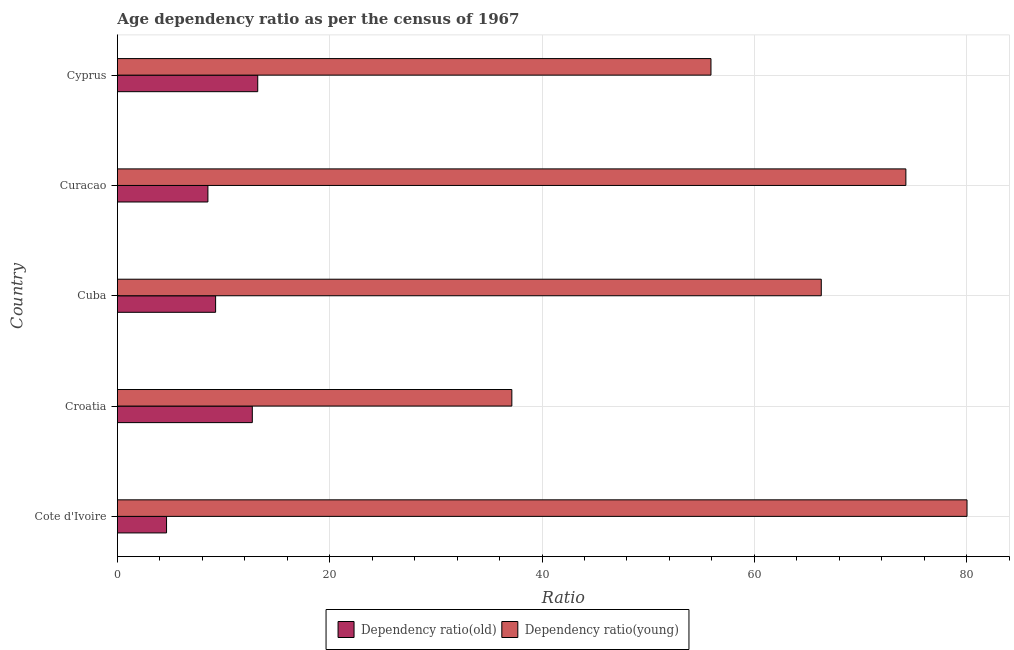Are the number of bars per tick equal to the number of legend labels?
Your answer should be compact. Yes. Are the number of bars on each tick of the Y-axis equal?
Give a very brief answer. Yes. What is the label of the 2nd group of bars from the top?
Ensure brevity in your answer.  Curacao. What is the age dependency ratio(old) in Curacao?
Provide a short and direct response. 8.52. Across all countries, what is the maximum age dependency ratio(young)?
Ensure brevity in your answer.  80.03. Across all countries, what is the minimum age dependency ratio(old)?
Give a very brief answer. 4.63. In which country was the age dependency ratio(old) maximum?
Give a very brief answer. Cyprus. In which country was the age dependency ratio(young) minimum?
Give a very brief answer. Croatia. What is the total age dependency ratio(old) in the graph?
Make the answer very short. 48.33. What is the difference between the age dependency ratio(old) in Cote d'Ivoire and that in Cyprus?
Your answer should be compact. -8.59. What is the difference between the age dependency ratio(young) in Croatia and the age dependency ratio(old) in Cyprus?
Keep it short and to the point. 23.94. What is the average age dependency ratio(young) per country?
Make the answer very short. 62.73. What is the difference between the age dependency ratio(old) and age dependency ratio(young) in Cuba?
Make the answer very short. -57.05. In how many countries, is the age dependency ratio(young) greater than 24 ?
Offer a very short reply. 5. What is the ratio of the age dependency ratio(old) in Cote d'Ivoire to that in Cyprus?
Offer a very short reply. 0.35. Is the age dependency ratio(old) in Cote d'Ivoire less than that in Cyprus?
Offer a terse response. Yes. What is the difference between the highest and the second highest age dependency ratio(young)?
Your answer should be very brief. 5.76. What is the difference between the highest and the lowest age dependency ratio(old)?
Provide a short and direct response. 8.59. In how many countries, is the age dependency ratio(old) greater than the average age dependency ratio(old) taken over all countries?
Give a very brief answer. 2. What does the 2nd bar from the top in Cuba represents?
Ensure brevity in your answer.  Dependency ratio(old). What does the 2nd bar from the bottom in Croatia represents?
Provide a short and direct response. Dependency ratio(young). Are all the bars in the graph horizontal?
Your answer should be compact. Yes. Are the values on the major ticks of X-axis written in scientific E-notation?
Offer a terse response. No. Does the graph contain any zero values?
Give a very brief answer. No. Does the graph contain grids?
Give a very brief answer. Yes. What is the title of the graph?
Ensure brevity in your answer.  Age dependency ratio as per the census of 1967. What is the label or title of the X-axis?
Ensure brevity in your answer.  Ratio. What is the Ratio of Dependency ratio(old) in Cote d'Ivoire?
Keep it short and to the point. 4.63. What is the Ratio of Dependency ratio(young) in Cote d'Ivoire?
Your answer should be very brief. 80.03. What is the Ratio of Dependency ratio(old) in Croatia?
Offer a very short reply. 12.71. What is the Ratio of Dependency ratio(young) in Croatia?
Make the answer very short. 37.15. What is the Ratio in Dependency ratio(old) in Cuba?
Offer a very short reply. 9.25. What is the Ratio of Dependency ratio(young) in Cuba?
Offer a very short reply. 66.3. What is the Ratio of Dependency ratio(old) in Curacao?
Your answer should be compact. 8.52. What is the Ratio of Dependency ratio(young) in Curacao?
Offer a terse response. 74.27. What is the Ratio in Dependency ratio(old) in Cyprus?
Your response must be concise. 13.22. What is the Ratio in Dependency ratio(young) in Cyprus?
Your answer should be compact. 55.91. Across all countries, what is the maximum Ratio in Dependency ratio(old)?
Offer a terse response. 13.22. Across all countries, what is the maximum Ratio in Dependency ratio(young)?
Make the answer very short. 80.03. Across all countries, what is the minimum Ratio of Dependency ratio(old)?
Provide a succinct answer. 4.63. Across all countries, what is the minimum Ratio in Dependency ratio(young)?
Make the answer very short. 37.15. What is the total Ratio in Dependency ratio(old) in the graph?
Keep it short and to the point. 48.33. What is the total Ratio of Dependency ratio(young) in the graph?
Provide a succinct answer. 313.66. What is the difference between the Ratio of Dependency ratio(old) in Cote d'Ivoire and that in Croatia?
Make the answer very short. -8.08. What is the difference between the Ratio of Dependency ratio(young) in Cote d'Ivoire and that in Croatia?
Your response must be concise. 42.87. What is the difference between the Ratio in Dependency ratio(old) in Cote d'Ivoire and that in Cuba?
Your answer should be very brief. -4.62. What is the difference between the Ratio in Dependency ratio(young) in Cote d'Ivoire and that in Cuba?
Your response must be concise. 13.73. What is the difference between the Ratio of Dependency ratio(old) in Cote d'Ivoire and that in Curacao?
Offer a very short reply. -3.9. What is the difference between the Ratio in Dependency ratio(young) in Cote d'Ivoire and that in Curacao?
Provide a short and direct response. 5.76. What is the difference between the Ratio of Dependency ratio(old) in Cote d'Ivoire and that in Cyprus?
Your response must be concise. -8.59. What is the difference between the Ratio in Dependency ratio(young) in Cote d'Ivoire and that in Cyprus?
Make the answer very short. 24.12. What is the difference between the Ratio in Dependency ratio(old) in Croatia and that in Cuba?
Offer a terse response. 3.46. What is the difference between the Ratio in Dependency ratio(young) in Croatia and that in Cuba?
Your answer should be very brief. -29.15. What is the difference between the Ratio of Dependency ratio(old) in Croatia and that in Curacao?
Give a very brief answer. 4.18. What is the difference between the Ratio of Dependency ratio(young) in Croatia and that in Curacao?
Ensure brevity in your answer.  -37.12. What is the difference between the Ratio in Dependency ratio(old) in Croatia and that in Cyprus?
Keep it short and to the point. -0.51. What is the difference between the Ratio of Dependency ratio(young) in Croatia and that in Cyprus?
Provide a succinct answer. -18.76. What is the difference between the Ratio of Dependency ratio(old) in Cuba and that in Curacao?
Your response must be concise. 0.73. What is the difference between the Ratio in Dependency ratio(young) in Cuba and that in Curacao?
Provide a succinct answer. -7.97. What is the difference between the Ratio of Dependency ratio(old) in Cuba and that in Cyprus?
Make the answer very short. -3.97. What is the difference between the Ratio of Dependency ratio(young) in Cuba and that in Cyprus?
Your response must be concise. 10.39. What is the difference between the Ratio in Dependency ratio(old) in Curacao and that in Cyprus?
Give a very brief answer. -4.69. What is the difference between the Ratio of Dependency ratio(young) in Curacao and that in Cyprus?
Your answer should be compact. 18.36. What is the difference between the Ratio of Dependency ratio(old) in Cote d'Ivoire and the Ratio of Dependency ratio(young) in Croatia?
Ensure brevity in your answer.  -32.53. What is the difference between the Ratio of Dependency ratio(old) in Cote d'Ivoire and the Ratio of Dependency ratio(young) in Cuba?
Your answer should be very brief. -61.67. What is the difference between the Ratio of Dependency ratio(old) in Cote d'Ivoire and the Ratio of Dependency ratio(young) in Curacao?
Provide a succinct answer. -69.64. What is the difference between the Ratio of Dependency ratio(old) in Cote d'Ivoire and the Ratio of Dependency ratio(young) in Cyprus?
Provide a succinct answer. -51.28. What is the difference between the Ratio in Dependency ratio(old) in Croatia and the Ratio in Dependency ratio(young) in Cuba?
Keep it short and to the point. -53.59. What is the difference between the Ratio of Dependency ratio(old) in Croatia and the Ratio of Dependency ratio(young) in Curacao?
Your answer should be very brief. -61.56. What is the difference between the Ratio of Dependency ratio(old) in Croatia and the Ratio of Dependency ratio(young) in Cyprus?
Give a very brief answer. -43.2. What is the difference between the Ratio in Dependency ratio(old) in Cuba and the Ratio in Dependency ratio(young) in Curacao?
Offer a terse response. -65.02. What is the difference between the Ratio in Dependency ratio(old) in Cuba and the Ratio in Dependency ratio(young) in Cyprus?
Offer a very short reply. -46.66. What is the difference between the Ratio in Dependency ratio(old) in Curacao and the Ratio in Dependency ratio(young) in Cyprus?
Offer a very short reply. -47.39. What is the average Ratio in Dependency ratio(old) per country?
Offer a terse response. 9.67. What is the average Ratio in Dependency ratio(young) per country?
Your answer should be compact. 62.73. What is the difference between the Ratio in Dependency ratio(old) and Ratio in Dependency ratio(young) in Cote d'Ivoire?
Provide a short and direct response. -75.4. What is the difference between the Ratio in Dependency ratio(old) and Ratio in Dependency ratio(young) in Croatia?
Offer a very short reply. -24.45. What is the difference between the Ratio of Dependency ratio(old) and Ratio of Dependency ratio(young) in Cuba?
Keep it short and to the point. -57.05. What is the difference between the Ratio of Dependency ratio(old) and Ratio of Dependency ratio(young) in Curacao?
Keep it short and to the point. -65.75. What is the difference between the Ratio in Dependency ratio(old) and Ratio in Dependency ratio(young) in Cyprus?
Provide a short and direct response. -42.69. What is the ratio of the Ratio in Dependency ratio(old) in Cote d'Ivoire to that in Croatia?
Offer a very short reply. 0.36. What is the ratio of the Ratio of Dependency ratio(young) in Cote d'Ivoire to that in Croatia?
Provide a short and direct response. 2.15. What is the ratio of the Ratio in Dependency ratio(old) in Cote d'Ivoire to that in Cuba?
Give a very brief answer. 0.5. What is the ratio of the Ratio of Dependency ratio(young) in Cote d'Ivoire to that in Cuba?
Your answer should be very brief. 1.21. What is the ratio of the Ratio of Dependency ratio(old) in Cote d'Ivoire to that in Curacao?
Provide a short and direct response. 0.54. What is the ratio of the Ratio in Dependency ratio(young) in Cote d'Ivoire to that in Curacao?
Ensure brevity in your answer.  1.08. What is the ratio of the Ratio of Dependency ratio(old) in Cote d'Ivoire to that in Cyprus?
Give a very brief answer. 0.35. What is the ratio of the Ratio of Dependency ratio(young) in Cote d'Ivoire to that in Cyprus?
Offer a terse response. 1.43. What is the ratio of the Ratio of Dependency ratio(old) in Croatia to that in Cuba?
Your answer should be compact. 1.37. What is the ratio of the Ratio in Dependency ratio(young) in Croatia to that in Cuba?
Offer a terse response. 0.56. What is the ratio of the Ratio of Dependency ratio(old) in Croatia to that in Curacao?
Your response must be concise. 1.49. What is the ratio of the Ratio of Dependency ratio(young) in Croatia to that in Curacao?
Your answer should be compact. 0.5. What is the ratio of the Ratio in Dependency ratio(old) in Croatia to that in Cyprus?
Offer a very short reply. 0.96. What is the ratio of the Ratio of Dependency ratio(young) in Croatia to that in Cyprus?
Your answer should be compact. 0.66. What is the ratio of the Ratio of Dependency ratio(old) in Cuba to that in Curacao?
Your answer should be compact. 1.09. What is the ratio of the Ratio in Dependency ratio(young) in Cuba to that in Curacao?
Make the answer very short. 0.89. What is the ratio of the Ratio of Dependency ratio(old) in Cuba to that in Cyprus?
Offer a terse response. 0.7. What is the ratio of the Ratio in Dependency ratio(young) in Cuba to that in Cyprus?
Your response must be concise. 1.19. What is the ratio of the Ratio of Dependency ratio(old) in Curacao to that in Cyprus?
Provide a succinct answer. 0.64. What is the ratio of the Ratio of Dependency ratio(young) in Curacao to that in Cyprus?
Provide a short and direct response. 1.33. What is the difference between the highest and the second highest Ratio of Dependency ratio(old)?
Give a very brief answer. 0.51. What is the difference between the highest and the second highest Ratio of Dependency ratio(young)?
Provide a short and direct response. 5.76. What is the difference between the highest and the lowest Ratio in Dependency ratio(old)?
Provide a short and direct response. 8.59. What is the difference between the highest and the lowest Ratio of Dependency ratio(young)?
Your response must be concise. 42.87. 